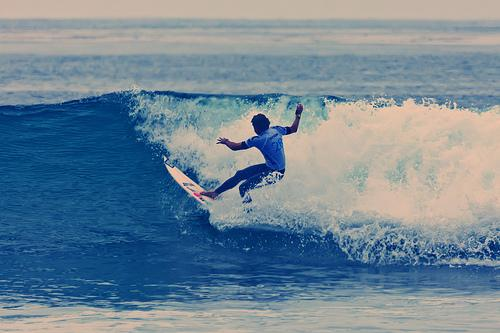Based on the given information, what type of object is most commonly mentioned in the image data? The surfboard and the man surfing are the most commonly mentioned objects in the data. Count and describe the different sections of the wave in the image. There are 3 sections: unbroken section, broken section, and white water on the wave. Examine the quality of the image focusing on the details and clarity of the objects present. The image quality seems to be high, as fine details like the man's curly hair and individual sections of the wave are visible. Provide a brief description of the man's appearance and his board. The man has curly black hair, wears a short sleeve blue shirt with number 28, and rides a white surfboard. Analyze the positioning of the surfer's body in relation to the wave. The surfer has his right foot forward, arms out at his sides, and is towards the broken section of the wave. In your own words, briefly explain a possible sentiment or emotion that one might feel looking at this image. Excitement or inspiration, seeing the man skillfully riding the wave and enjoying the sport. What number can be seen in the image, and where is it located? The number 28 can be seen on the man's blue rashguard shirt. Describe the colors and type of water visible in the image. Blue and dark blue water can be seen, along with white water on the wave and still water behind it. Identify the main activity taking place in the image. A man is surfing on a wave in the ocean. How many times does the phrase "a man on a white surfboard" appear in the image? Twice. 